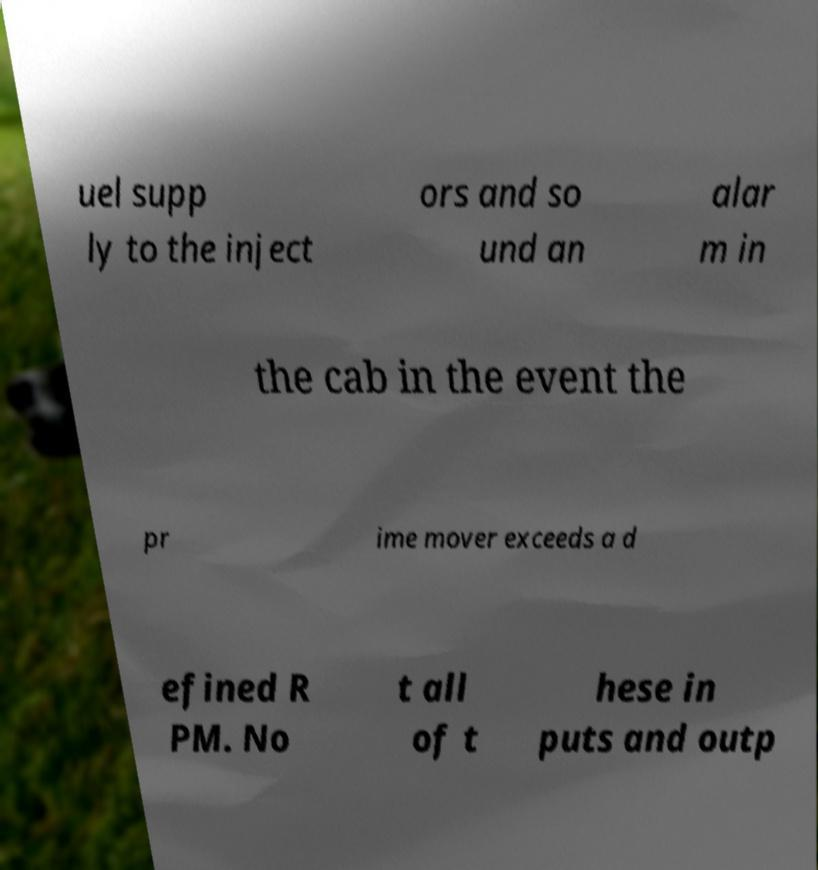Please read and relay the text visible in this image. What does it say? uel supp ly to the inject ors and so und an alar m in the cab in the event the pr ime mover exceeds a d efined R PM. No t all of t hese in puts and outp 